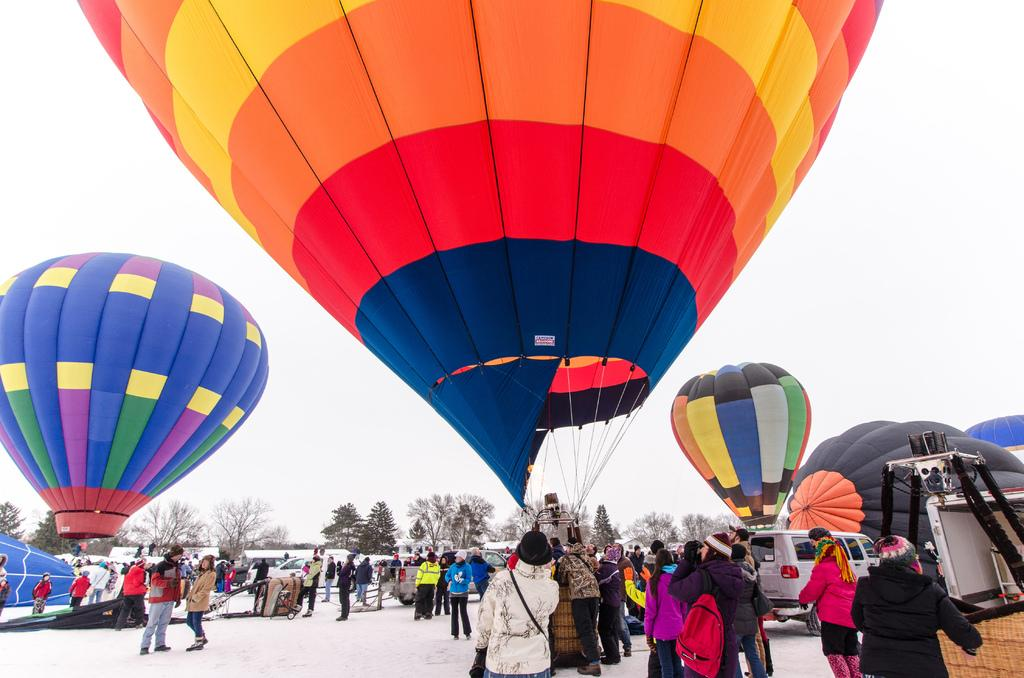What can be seen in the image involving multiple individuals? There are groups of people in the image. What is located in the middle of the image? There are colorful parachutes in the middle of the image. What type of vegetation is visible in the background of the image? There are groups of trees in the background of the image. How many chairs are present in the image? There is no mention of chairs in the image, so it is impossible to determine their number. Are there any chickens visible in the image? There is no mention of chickens in the image, so it is impossible to determine their presence. 